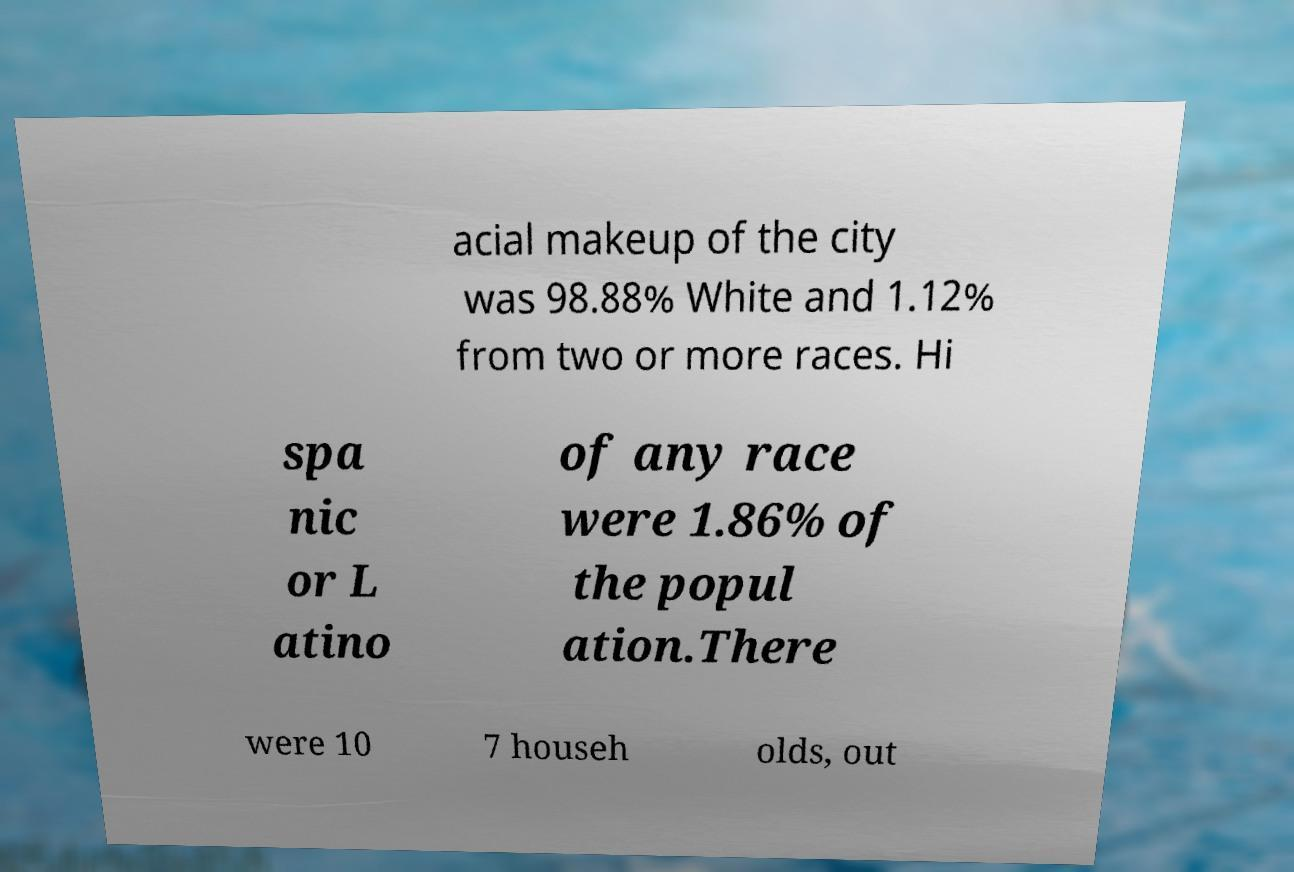Can you read and provide the text displayed in the image?This photo seems to have some interesting text. Can you extract and type it out for me? acial makeup of the city was 98.88% White and 1.12% from two or more races. Hi spa nic or L atino of any race were 1.86% of the popul ation.There were 10 7 househ olds, out 